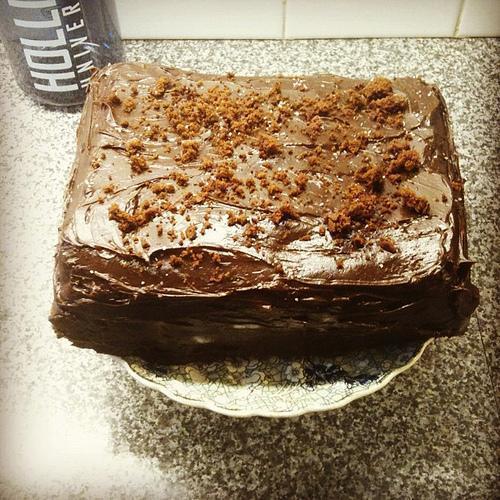How many cakes are there?
Give a very brief answer. 1. 